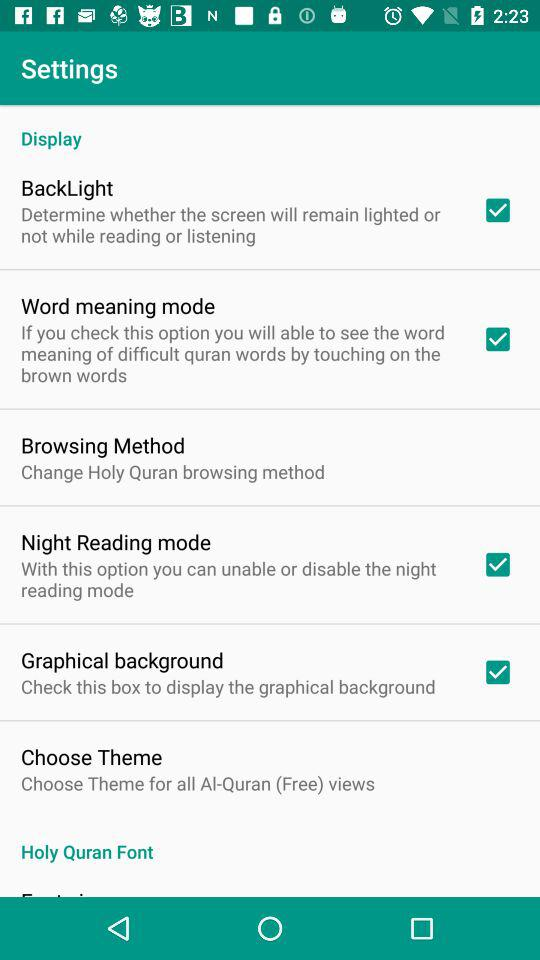How many checkboxes are in this settings screen? 4 